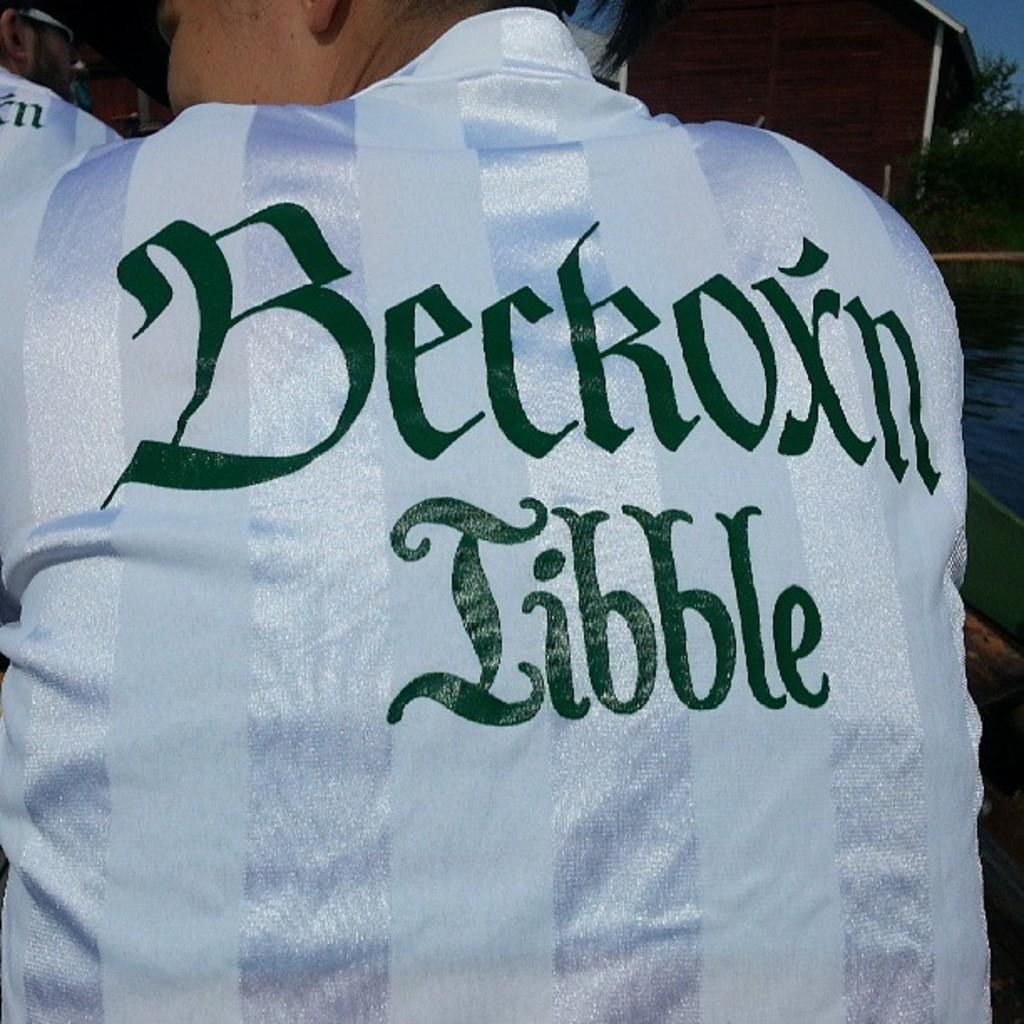<image>
Offer a succinct explanation of the picture presented. The back of a white jersey that says "Beckoxn Libble" in green lettering. 